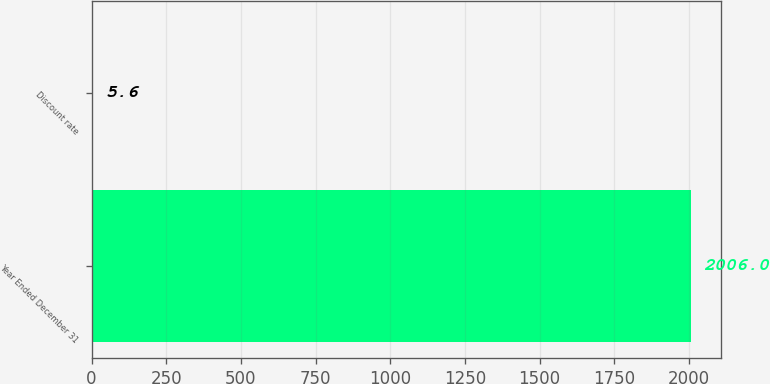Convert chart to OTSL. <chart><loc_0><loc_0><loc_500><loc_500><bar_chart><fcel>Year Ended December 31<fcel>Discount rate<nl><fcel>2006<fcel>5.6<nl></chart> 